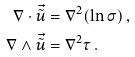<formula> <loc_0><loc_0><loc_500><loc_500>\nabla \cdot \vec { \tilde { u } } & = \nabla ^ { 2 } ( \ln \sigma ) \, , \\ \nabla \wedge \vec { \tilde { u } } & = \nabla ^ { 2 } \tau \, .</formula> 